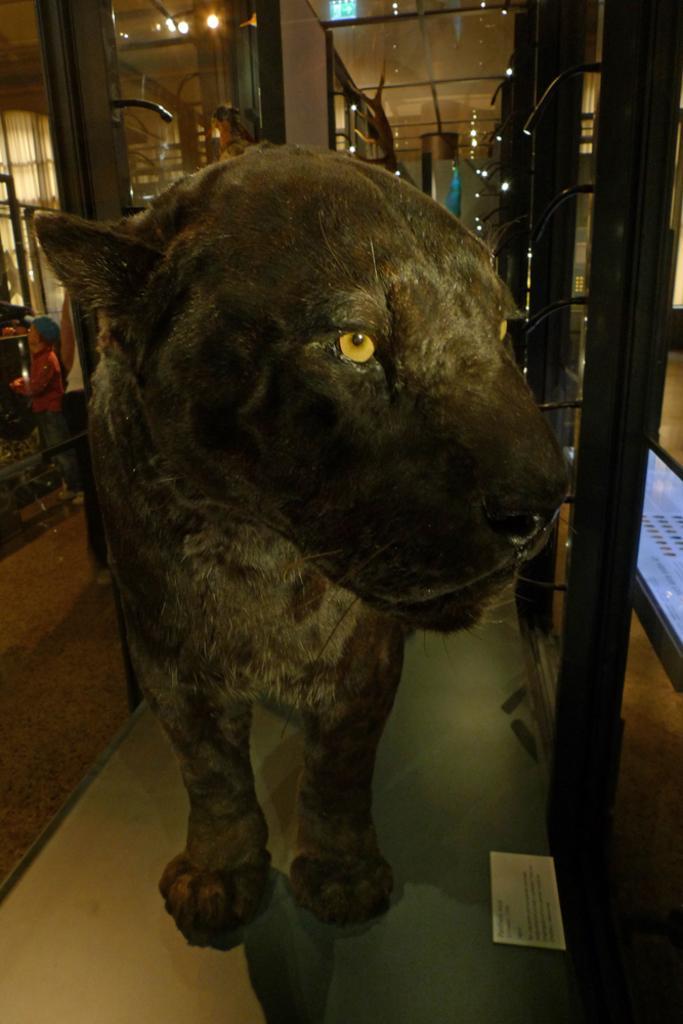Could you give a brief overview of what you see in this image? In this image we can see a statue of an animal on the surface and a paper beside it. We can also see some metal poles, two persons standing and some lights. 